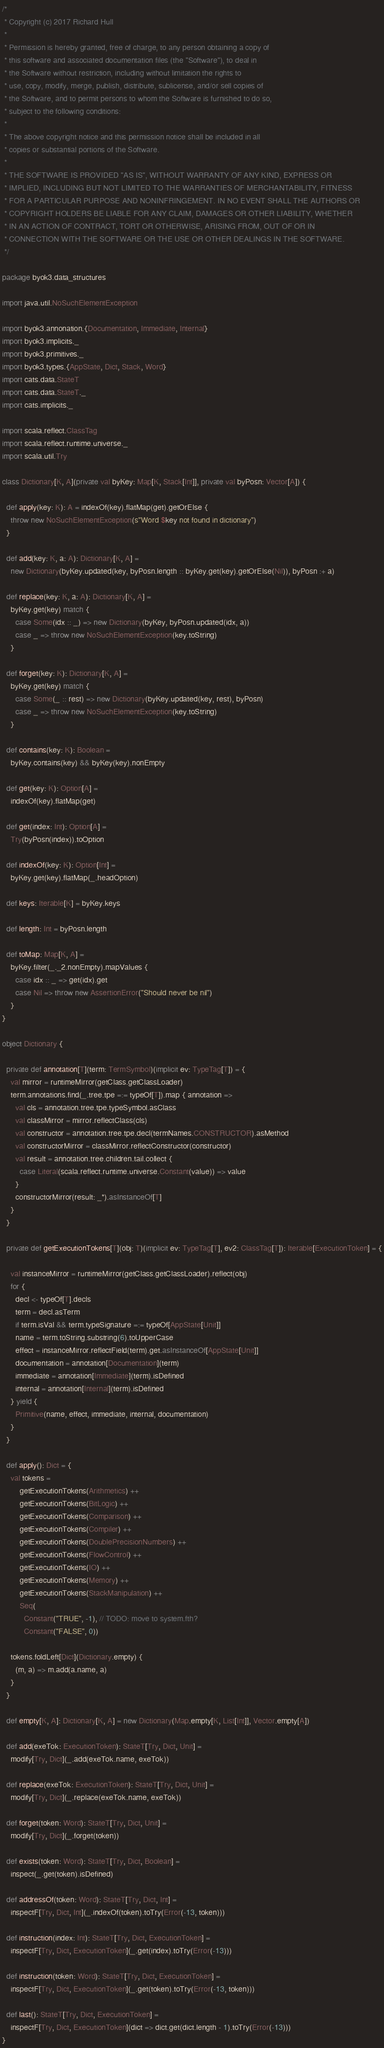<code> <loc_0><loc_0><loc_500><loc_500><_Scala_>/*
 * Copyright (c) 2017 Richard Hull
 *
 * Permission is hereby granted, free of charge, to any person obtaining a copy of
 * this software and associated documentation files (the "Software"), to deal in
 * the Software without restriction, including without limitation the rights to
 * use, copy, modify, merge, publish, distribute, sublicense, and/or sell copies of
 * the Software, and to permit persons to whom the Software is furnished to do so,
 * subject to the following conditions:
 *
 * The above copyright notice and this permission notice shall be included in all
 * copies or substantial portions of the Software.
 *
 * THE SOFTWARE IS PROVIDED "AS IS", WITHOUT WARRANTY OF ANY KIND, EXPRESS OR
 * IMPLIED, INCLUDING BUT NOT LIMITED TO THE WARRANTIES OF MERCHANTABILITY, FITNESS
 * FOR A PARTICULAR PURPOSE AND NONINFRINGEMENT. IN NO EVENT SHALL THE AUTHORS OR
 * COPYRIGHT HOLDERS BE LIABLE FOR ANY CLAIM, DAMAGES OR OTHER LIABILITY, WHETHER
 * IN AN ACTION OF CONTRACT, TORT OR OTHERWISE, ARISING FROM, OUT OF OR IN
 * CONNECTION WITH THE SOFTWARE OR THE USE OR OTHER DEALINGS IN THE SOFTWARE.
 */

package byok3.data_structures

import java.util.NoSuchElementException

import byok3.annonation.{Documentation, Immediate, Internal}
import byok3.implicits._
import byok3.primitives._
import byok3.types.{AppState, Dict, Stack, Word}
import cats.data.StateT
import cats.data.StateT._
import cats.implicits._

import scala.reflect.ClassTag
import scala.reflect.runtime.universe._
import scala.util.Try

class Dictionary[K, A](private val byKey: Map[K, Stack[Int]], private val byPosn: Vector[A]) {

  def apply(key: K): A = indexOf(key).flatMap(get).getOrElse {
    throw new NoSuchElementException(s"Word $key not found in dictionary")
  }

  def add(key: K, a: A): Dictionary[K, A] =
    new Dictionary(byKey.updated(key, byPosn.length :: byKey.get(key).getOrElse(Nil)), byPosn :+ a)

  def replace(key: K, a: A): Dictionary[K, A] =
    byKey.get(key) match {
      case Some(idx :: _) => new Dictionary(byKey, byPosn.updated(idx, a))
      case _ => throw new NoSuchElementException(key.toString)
    }

  def forget(key: K): Dictionary[K, A] =
    byKey.get(key) match {
      case Some(_ :: rest) => new Dictionary(byKey.updated(key, rest), byPosn)
      case _ => throw new NoSuchElementException(key.toString)
    }

  def contains(key: K): Boolean =
    byKey.contains(key) && byKey(key).nonEmpty

  def get(key: K): Option[A] =
    indexOf(key).flatMap(get)

  def get(index: Int): Option[A] =
    Try(byPosn(index)).toOption

  def indexOf(key: K): Option[Int] =
    byKey.get(key).flatMap(_.headOption)

  def keys: Iterable[K] = byKey.keys

  def length: Int = byPosn.length

  def toMap: Map[K, A] =
    byKey.filter(_._2.nonEmpty).mapValues {
      case idx :: _ => get(idx).get
      case Nil => throw new AssertionError("Should never be nil")
    }
}

object Dictionary {

  private def annotation[T](term: TermSymbol)(implicit ev: TypeTag[T]) = {
    val mirror = runtimeMirror(getClass.getClassLoader)
    term.annotations.find(_.tree.tpe =:= typeOf[T]).map { annotation =>
      val cls = annotation.tree.tpe.typeSymbol.asClass
      val classMirror = mirror.reflectClass(cls)
      val constructor = annotation.tree.tpe.decl(termNames.CONSTRUCTOR).asMethod
      val constructorMirror = classMirror.reflectConstructor(constructor)
      val result = annotation.tree.children.tail.collect {
        case Literal(scala.reflect.runtime.universe.Constant(value)) => value
      }
      constructorMirror(result: _*).asInstanceOf[T]
    }
  }

  private def getExecutionTokens[T](obj: T)(implicit ev: TypeTag[T], ev2: ClassTag[T]): Iterable[ExecutionToken] = {

    val instanceMirror = runtimeMirror(getClass.getClassLoader).reflect(obj)
    for {
      decl <- typeOf[T].decls
      term = decl.asTerm
      if term.isVal && term.typeSignature =:= typeOf[AppState[Unit]]
      name = term.toString.substring(6).toUpperCase
      effect = instanceMirror.reflectField(term).get.asInstanceOf[AppState[Unit]]
      documentation = annotation[Documentation](term)
      immediate = annotation[Immediate](term).isDefined
      internal = annotation[Internal](term).isDefined
    } yield {
      Primitive(name, effect, immediate, internal, documentation)
    }
  }

  def apply(): Dict = {
    val tokens =
        getExecutionTokens(Arithmetics) ++
        getExecutionTokens(BitLogic) ++
        getExecutionTokens(Comparison) ++
        getExecutionTokens(Compiler) ++
        getExecutionTokens(DoublePrecisionNumbers) ++
        getExecutionTokens(FlowControl) ++
        getExecutionTokens(IO) ++
        getExecutionTokens(Memory) ++
        getExecutionTokens(StackManipulation) ++
        Seq(
          Constant("TRUE", -1), // TODO: move to system.fth?
          Constant("FALSE", 0))

    tokens.foldLeft[Dict](Dictionary.empty) {
      (m, a) => m.add(a.name, a)
    }
  }

  def empty[K, A]: Dictionary[K, A] = new Dictionary(Map.empty[K, List[Int]], Vector.empty[A])

  def add(exeTok: ExecutionToken): StateT[Try, Dict, Unit] =
    modify[Try, Dict](_.add(exeTok.name, exeTok))

  def replace(exeTok: ExecutionToken): StateT[Try, Dict, Unit] =
    modify[Try, Dict](_.replace(exeTok.name, exeTok))

  def forget(token: Word): StateT[Try, Dict, Unit] =
    modify[Try, Dict](_.forget(token))

  def exists(token: Word): StateT[Try, Dict, Boolean] =
    inspect(_.get(token).isDefined)

  def addressOf(token: Word): StateT[Try, Dict, Int] =
    inspectF[Try, Dict, Int](_.indexOf(token).toTry(Error(-13, token)))

  def instruction(index: Int): StateT[Try, Dict, ExecutionToken] =
    inspectF[Try, Dict, ExecutionToken](_.get(index).toTry(Error(-13)))

  def instruction(token: Word): StateT[Try, Dict, ExecutionToken] =
    inspectF[Try, Dict, ExecutionToken](_.get(token).toTry(Error(-13, token)))

  def last(): StateT[Try, Dict, ExecutionToken] =
    inspectF[Try, Dict, ExecutionToken](dict => dict.get(dict.length - 1).toTry(Error(-13)))
}

</code> 